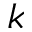<formula> <loc_0><loc_0><loc_500><loc_500>k</formula> 